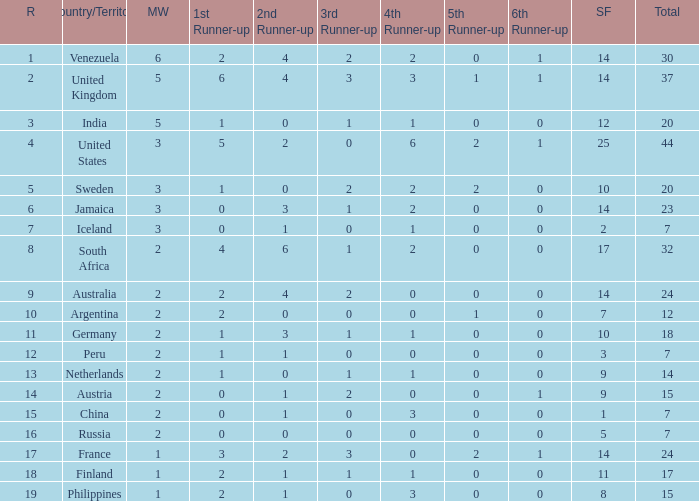In which rank can the united states be found? 1.0. Could you help me parse every detail presented in this table? {'header': ['R', 'Country/Territory', 'MW', '1st Runner-up', '2nd Runner-up', '3rd Runner-up', '4th Runner-up', '5th Runner-up', '6th Runner-up', 'SF', 'Total'], 'rows': [['1', 'Venezuela', '6', '2', '4', '2', '2', '0', '1', '14', '30'], ['2', 'United Kingdom', '5', '6', '4', '3', '3', '1', '1', '14', '37'], ['3', 'India', '5', '1', '0', '1', '1', '0', '0', '12', '20'], ['4', 'United States', '3', '5', '2', '0', '6', '2', '1', '25', '44'], ['5', 'Sweden', '3', '1', '0', '2', '2', '2', '0', '10', '20'], ['6', 'Jamaica', '3', '0', '3', '1', '2', '0', '0', '14', '23'], ['7', 'Iceland', '3', '0', '1', '0', '1', '0', '0', '2', '7'], ['8', 'South Africa', '2', '4', '6', '1', '2', '0', '0', '17', '32'], ['9', 'Australia', '2', '2', '4', '2', '0', '0', '0', '14', '24'], ['10', 'Argentina', '2', '2', '0', '0', '0', '1', '0', '7', '12'], ['11', 'Germany', '2', '1', '3', '1', '1', '0', '0', '10', '18'], ['12', 'Peru', '2', '1', '1', '0', '0', '0', '0', '3', '7'], ['13', 'Netherlands', '2', '1', '0', '1', '1', '0', '0', '9', '14'], ['14', 'Austria', '2', '0', '1', '2', '0', '0', '1', '9', '15'], ['15', 'China', '2', '0', '1', '0', '3', '0', '0', '1', '7'], ['16', 'Russia', '2', '0', '0', '0', '0', '0', '0', '5', '7'], ['17', 'France', '1', '3', '2', '3', '0', '2', '1', '14', '24'], ['18', 'Finland', '1', '2', '1', '1', '1', '0', '0', '11', '17'], ['19', 'Philippines', '1', '2', '1', '0', '3', '0', '0', '8', '15']]} 